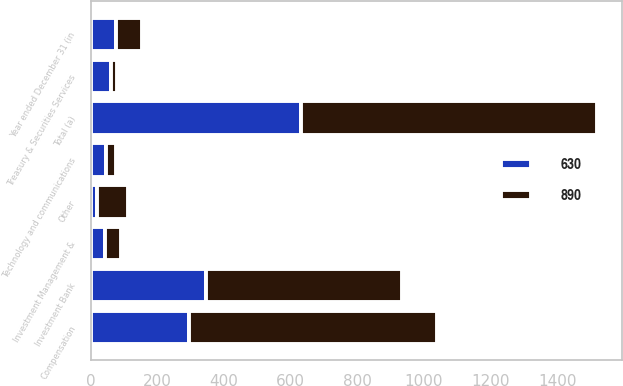Convert chart to OTSL. <chart><loc_0><loc_0><loc_500><loc_500><stacked_bar_chart><ecel><fcel>Year ended December 31 (in<fcel>Compensation<fcel>Technology and communications<fcel>Other<fcel>Total (a)<fcel>Investment Bank<fcel>Treasury & Securities Services<fcel>Investment Management &<nl><fcel>630<fcel>76.5<fcel>294<fcel>47<fcel>19<fcel>630<fcel>347<fcel>61<fcel>44<nl><fcel>890<fcel>76.5<fcel>746<fcel>30<fcel>92<fcel>890<fcel>587<fcel>17<fcel>47<nl></chart> 